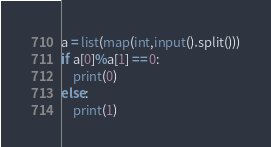Convert code to text. <code><loc_0><loc_0><loc_500><loc_500><_Python_>a = list(map(int,input().split()))
if a[0]%a[1] == 0:
    print(0)
else:
    print(1)</code> 